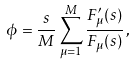<formula> <loc_0><loc_0><loc_500><loc_500>\phi = \frac { s } { M } \sum _ { \mu = 1 } ^ { M } \frac { F _ { \mu } ^ { \prime } ( s ) } { F _ { \mu } ( s ) } \, ,</formula> 